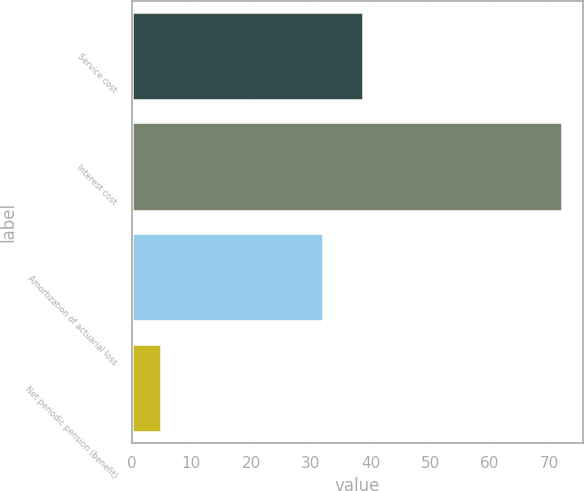Convert chart to OTSL. <chart><loc_0><loc_0><loc_500><loc_500><bar_chart><fcel>Service cost<fcel>Interest cost<fcel>Amortization of actuarial loss<fcel>Net periodic pension (benefit)<nl><fcel>38.7<fcel>72<fcel>32<fcel>5<nl></chart> 